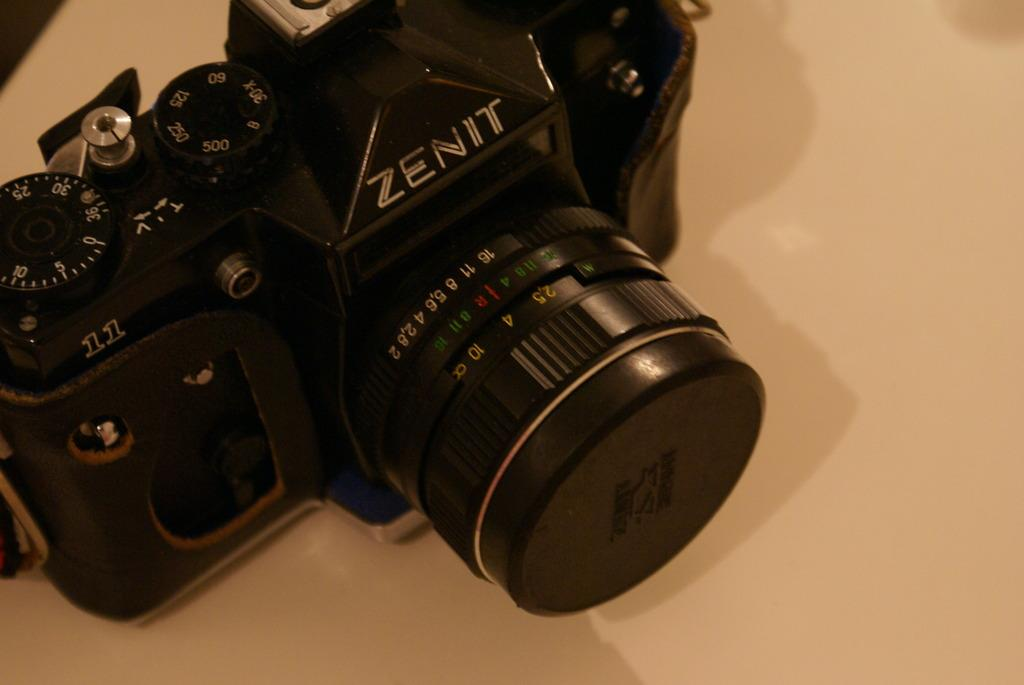What object is the main subject of the image? There is a camera in the image. What is the color of the surface the camera is placed on? The camera is on a white surface. Can you describe any additional features in the image? There is a shadow visible in the image. What time does the clock in the image display? There is no clock present in the image. What type of sign is visible in the image? There are no signs visible in the image. 